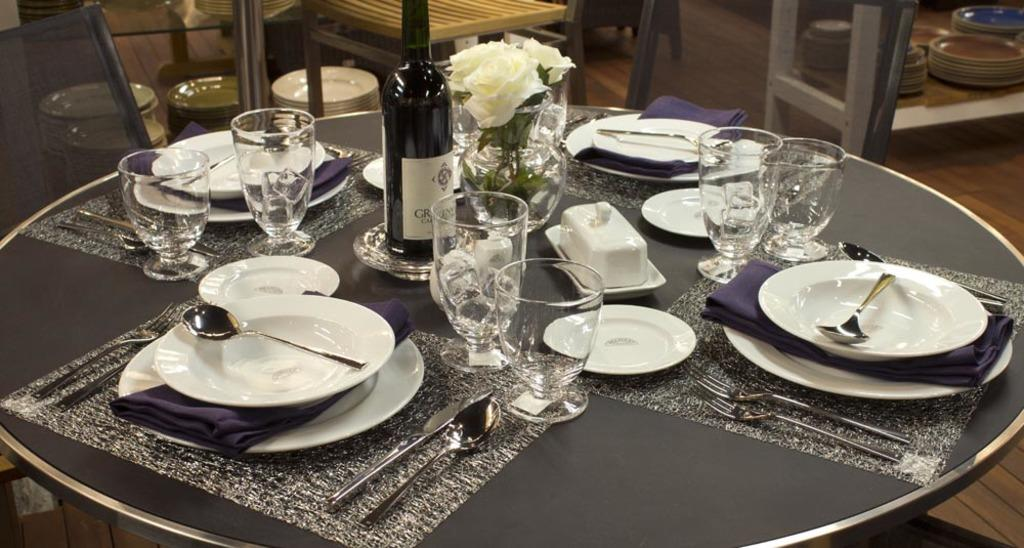What type of tableware can be seen on the table in the image? There are plates, spoons, and forks on the table in the image. What type of drinkware is present on the table? There are glasses on the table. What is covering the table? There is a cloth on the table. What type of decoration is present on the table? There is a flower vase on the table. What type of beverage is visible on the table? There is a wine bottle on the table. What can be seen in the background of the image? There are chairs and plates in the background. Reasoning: Let' Let's think step by step in order to produce the conversation. We start by identifying the main objects on the table, which include plates, spoons, forks, glasses, a cloth, a flower vase, and a wine bottle. Then, we expand the conversation to include the background, noting the presence of chairs and plates. Each question is designed to elicit a specific detail about the image that is known from the provided facts. Absurd Question/Answer: What type of farm animals can be seen in the image? There are no farm animals present in the image. What type of noise can be heard coming from the cook in the image? There is no cook or noise present in the image. 